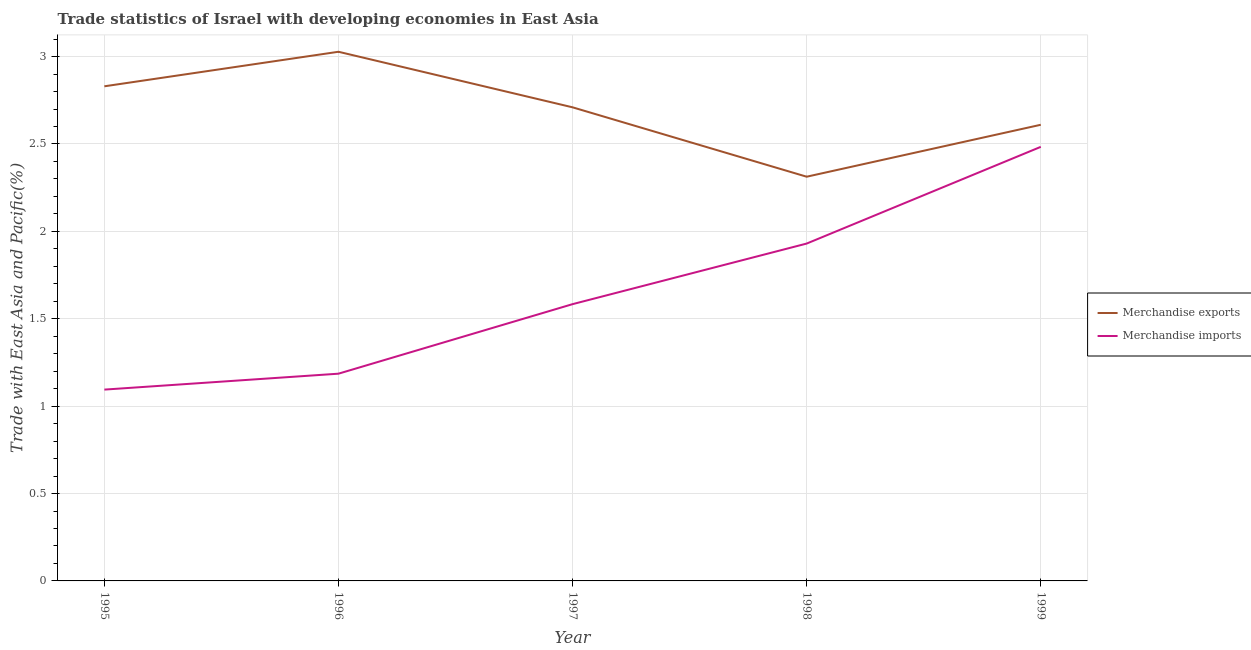How many different coloured lines are there?
Provide a short and direct response. 2. Does the line corresponding to merchandise exports intersect with the line corresponding to merchandise imports?
Your answer should be compact. No. Is the number of lines equal to the number of legend labels?
Your response must be concise. Yes. What is the merchandise exports in 1996?
Provide a succinct answer. 3.03. Across all years, what is the maximum merchandise imports?
Provide a succinct answer. 2.48. Across all years, what is the minimum merchandise exports?
Give a very brief answer. 2.31. What is the total merchandise exports in the graph?
Your answer should be compact. 13.49. What is the difference between the merchandise exports in 1995 and that in 1998?
Give a very brief answer. 0.52. What is the difference between the merchandise imports in 1999 and the merchandise exports in 1996?
Make the answer very short. -0.54. What is the average merchandise imports per year?
Your response must be concise. 1.66. In the year 1996, what is the difference between the merchandise exports and merchandise imports?
Your answer should be compact. 1.84. What is the ratio of the merchandise exports in 1996 to that in 1999?
Keep it short and to the point. 1.16. Is the merchandise exports in 1996 less than that in 1999?
Your answer should be compact. No. What is the difference between the highest and the second highest merchandise exports?
Keep it short and to the point. 0.2. What is the difference between the highest and the lowest merchandise imports?
Provide a short and direct response. 1.39. Does the merchandise exports monotonically increase over the years?
Make the answer very short. No. Are the values on the major ticks of Y-axis written in scientific E-notation?
Keep it short and to the point. No. Does the graph contain any zero values?
Make the answer very short. No. How many legend labels are there?
Give a very brief answer. 2. How are the legend labels stacked?
Provide a short and direct response. Vertical. What is the title of the graph?
Keep it short and to the point. Trade statistics of Israel with developing economies in East Asia. What is the label or title of the Y-axis?
Your response must be concise. Trade with East Asia and Pacific(%). What is the Trade with East Asia and Pacific(%) of Merchandise exports in 1995?
Ensure brevity in your answer.  2.83. What is the Trade with East Asia and Pacific(%) in Merchandise imports in 1995?
Provide a short and direct response. 1.09. What is the Trade with East Asia and Pacific(%) in Merchandise exports in 1996?
Ensure brevity in your answer.  3.03. What is the Trade with East Asia and Pacific(%) of Merchandise imports in 1996?
Offer a very short reply. 1.19. What is the Trade with East Asia and Pacific(%) in Merchandise exports in 1997?
Your response must be concise. 2.71. What is the Trade with East Asia and Pacific(%) in Merchandise imports in 1997?
Give a very brief answer. 1.58. What is the Trade with East Asia and Pacific(%) of Merchandise exports in 1998?
Your response must be concise. 2.31. What is the Trade with East Asia and Pacific(%) in Merchandise imports in 1998?
Offer a very short reply. 1.93. What is the Trade with East Asia and Pacific(%) of Merchandise exports in 1999?
Provide a short and direct response. 2.61. What is the Trade with East Asia and Pacific(%) of Merchandise imports in 1999?
Your answer should be very brief. 2.48. Across all years, what is the maximum Trade with East Asia and Pacific(%) of Merchandise exports?
Provide a succinct answer. 3.03. Across all years, what is the maximum Trade with East Asia and Pacific(%) in Merchandise imports?
Make the answer very short. 2.48. Across all years, what is the minimum Trade with East Asia and Pacific(%) in Merchandise exports?
Keep it short and to the point. 2.31. Across all years, what is the minimum Trade with East Asia and Pacific(%) in Merchandise imports?
Keep it short and to the point. 1.09. What is the total Trade with East Asia and Pacific(%) in Merchandise exports in the graph?
Your answer should be very brief. 13.49. What is the total Trade with East Asia and Pacific(%) in Merchandise imports in the graph?
Provide a short and direct response. 8.28. What is the difference between the Trade with East Asia and Pacific(%) in Merchandise exports in 1995 and that in 1996?
Offer a terse response. -0.2. What is the difference between the Trade with East Asia and Pacific(%) of Merchandise imports in 1995 and that in 1996?
Make the answer very short. -0.09. What is the difference between the Trade with East Asia and Pacific(%) of Merchandise exports in 1995 and that in 1997?
Your response must be concise. 0.12. What is the difference between the Trade with East Asia and Pacific(%) of Merchandise imports in 1995 and that in 1997?
Offer a very short reply. -0.49. What is the difference between the Trade with East Asia and Pacific(%) in Merchandise exports in 1995 and that in 1998?
Give a very brief answer. 0.52. What is the difference between the Trade with East Asia and Pacific(%) of Merchandise imports in 1995 and that in 1998?
Provide a short and direct response. -0.84. What is the difference between the Trade with East Asia and Pacific(%) in Merchandise exports in 1995 and that in 1999?
Make the answer very short. 0.22. What is the difference between the Trade with East Asia and Pacific(%) in Merchandise imports in 1995 and that in 1999?
Offer a terse response. -1.39. What is the difference between the Trade with East Asia and Pacific(%) in Merchandise exports in 1996 and that in 1997?
Ensure brevity in your answer.  0.32. What is the difference between the Trade with East Asia and Pacific(%) of Merchandise imports in 1996 and that in 1997?
Give a very brief answer. -0.4. What is the difference between the Trade with East Asia and Pacific(%) of Merchandise exports in 1996 and that in 1998?
Offer a very short reply. 0.71. What is the difference between the Trade with East Asia and Pacific(%) in Merchandise imports in 1996 and that in 1998?
Make the answer very short. -0.74. What is the difference between the Trade with East Asia and Pacific(%) in Merchandise exports in 1996 and that in 1999?
Offer a terse response. 0.42. What is the difference between the Trade with East Asia and Pacific(%) of Merchandise imports in 1996 and that in 1999?
Your answer should be very brief. -1.3. What is the difference between the Trade with East Asia and Pacific(%) in Merchandise exports in 1997 and that in 1998?
Your response must be concise. 0.4. What is the difference between the Trade with East Asia and Pacific(%) of Merchandise imports in 1997 and that in 1998?
Make the answer very short. -0.35. What is the difference between the Trade with East Asia and Pacific(%) of Merchandise exports in 1997 and that in 1999?
Provide a succinct answer. 0.1. What is the difference between the Trade with East Asia and Pacific(%) of Merchandise imports in 1997 and that in 1999?
Ensure brevity in your answer.  -0.9. What is the difference between the Trade with East Asia and Pacific(%) in Merchandise exports in 1998 and that in 1999?
Your answer should be very brief. -0.3. What is the difference between the Trade with East Asia and Pacific(%) in Merchandise imports in 1998 and that in 1999?
Your response must be concise. -0.55. What is the difference between the Trade with East Asia and Pacific(%) of Merchandise exports in 1995 and the Trade with East Asia and Pacific(%) of Merchandise imports in 1996?
Make the answer very short. 1.64. What is the difference between the Trade with East Asia and Pacific(%) in Merchandise exports in 1995 and the Trade with East Asia and Pacific(%) in Merchandise imports in 1997?
Your answer should be very brief. 1.25. What is the difference between the Trade with East Asia and Pacific(%) of Merchandise exports in 1995 and the Trade with East Asia and Pacific(%) of Merchandise imports in 1998?
Your answer should be very brief. 0.9. What is the difference between the Trade with East Asia and Pacific(%) of Merchandise exports in 1995 and the Trade with East Asia and Pacific(%) of Merchandise imports in 1999?
Ensure brevity in your answer.  0.35. What is the difference between the Trade with East Asia and Pacific(%) of Merchandise exports in 1996 and the Trade with East Asia and Pacific(%) of Merchandise imports in 1997?
Your answer should be very brief. 1.44. What is the difference between the Trade with East Asia and Pacific(%) of Merchandise exports in 1996 and the Trade with East Asia and Pacific(%) of Merchandise imports in 1998?
Offer a terse response. 1.1. What is the difference between the Trade with East Asia and Pacific(%) of Merchandise exports in 1996 and the Trade with East Asia and Pacific(%) of Merchandise imports in 1999?
Offer a terse response. 0.54. What is the difference between the Trade with East Asia and Pacific(%) of Merchandise exports in 1997 and the Trade with East Asia and Pacific(%) of Merchandise imports in 1998?
Provide a succinct answer. 0.78. What is the difference between the Trade with East Asia and Pacific(%) of Merchandise exports in 1997 and the Trade with East Asia and Pacific(%) of Merchandise imports in 1999?
Your answer should be very brief. 0.23. What is the difference between the Trade with East Asia and Pacific(%) of Merchandise exports in 1998 and the Trade with East Asia and Pacific(%) of Merchandise imports in 1999?
Give a very brief answer. -0.17. What is the average Trade with East Asia and Pacific(%) of Merchandise exports per year?
Provide a short and direct response. 2.7. What is the average Trade with East Asia and Pacific(%) in Merchandise imports per year?
Make the answer very short. 1.66. In the year 1995, what is the difference between the Trade with East Asia and Pacific(%) of Merchandise exports and Trade with East Asia and Pacific(%) of Merchandise imports?
Make the answer very short. 1.74. In the year 1996, what is the difference between the Trade with East Asia and Pacific(%) of Merchandise exports and Trade with East Asia and Pacific(%) of Merchandise imports?
Make the answer very short. 1.84. In the year 1997, what is the difference between the Trade with East Asia and Pacific(%) of Merchandise exports and Trade with East Asia and Pacific(%) of Merchandise imports?
Keep it short and to the point. 1.13. In the year 1998, what is the difference between the Trade with East Asia and Pacific(%) of Merchandise exports and Trade with East Asia and Pacific(%) of Merchandise imports?
Give a very brief answer. 0.38. In the year 1999, what is the difference between the Trade with East Asia and Pacific(%) of Merchandise exports and Trade with East Asia and Pacific(%) of Merchandise imports?
Offer a very short reply. 0.13. What is the ratio of the Trade with East Asia and Pacific(%) of Merchandise exports in 1995 to that in 1996?
Provide a short and direct response. 0.93. What is the ratio of the Trade with East Asia and Pacific(%) in Merchandise imports in 1995 to that in 1996?
Give a very brief answer. 0.92. What is the ratio of the Trade with East Asia and Pacific(%) of Merchandise exports in 1995 to that in 1997?
Make the answer very short. 1.04. What is the ratio of the Trade with East Asia and Pacific(%) in Merchandise imports in 1995 to that in 1997?
Your answer should be very brief. 0.69. What is the ratio of the Trade with East Asia and Pacific(%) of Merchandise exports in 1995 to that in 1998?
Keep it short and to the point. 1.22. What is the ratio of the Trade with East Asia and Pacific(%) in Merchandise imports in 1995 to that in 1998?
Keep it short and to the point. 0.57. What is the ratio of the Trade with East Asia and Pacific(%) of Merchandise exports in 1995 to that in 1999?
Offer a terse response. 1.08. What is the ratio of the Trade with East Asia and Pacific(%) of Merchandise imports in 1995 to that in 1999?
Make the answer very short. 0.44. What is the ratio of the Trade with East Asia and Pacific(%) of Merchandise exports in 1996 to that in 1997?
Offer a very short reply. 1.12. What is the ratio of the Trade with East Asia and Pacific(%) in Merchandise imports in 1996 to that in 1997?
Offer a terse response. 0.75. What is the ratio of the Trade with East Asia and Pacific(%) in Merchandise exports in 1996 to that in 1998?
Ensure brevity in your answer.  1.31. What is the ratio of the Trade with East Asia and Pacific(%) of Merchandise imports in 1996 to that in 1998?
Your answer should be very brief. 0.61. What is the ratio of the Trade with East Asia and Pacific(%) of Merchandise exports in 1996 to that in 1999?
Your answer should be compact. 1.16. What is the ratio of the Trade with East Asia and Pacific(%) of Merchandise imports in 1996 to that in 1999?
Provide a succinct answer. 0.48. What is the ratio of the Trade with East Asia and Pacific(%) in Merchandise exports in 1997 to that in 1998?
Give a very brief answer. 1.17. What is the ratio of the Trade with East Asia and Pacific(%) of Merchandise imports in 1997 to that in 1998?
Provide a succinct answer. 0.82. What is the ratio of the Trade with East Asia and Pacific(%) of Merchandise exports in 1997 to that in 1999?
Give a very brief answer. 1.04. What is the ratio of the Trade with East Asia and Pacific(%) of Merchandise imports in 1997 to that in 1999?
Keep it short and to the point. 0.64. What is the ratio of the Trade with East Asia and Pacific(%) of Merchandise exports in 1998 to that in 1999?
Ensure brevity in your answer.  0.89. What is the ratio of the Trade with East Asia and Pacific(%) of Merchandise imports in 1998 to that in 1999?
Your response must be concise. 0.78. What is the difference between the highest and the second highest Trade with East Asia and Pacific(%) in Merchandise exports?
Keep it short and to the point. 0.2. What is the difference between the highest and the second highest Trade with East Asia and Pacific(%) of Merchandise imports?
Your answer should be very brief. 0.55. What is the difference between the highest and the lowest Trade with East Asia and Pacific(%) in Merchandise exports?
Provide a short and direct response. 0.71. What is the difference between the highest and the lowest Trade with East Asia and Pacific(%) in Merchandise imports?
Give a very brief answer. 1.39. 